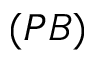<formula> <loc_0><loc_0><loc_500><loc_500>( P B )</formula> 